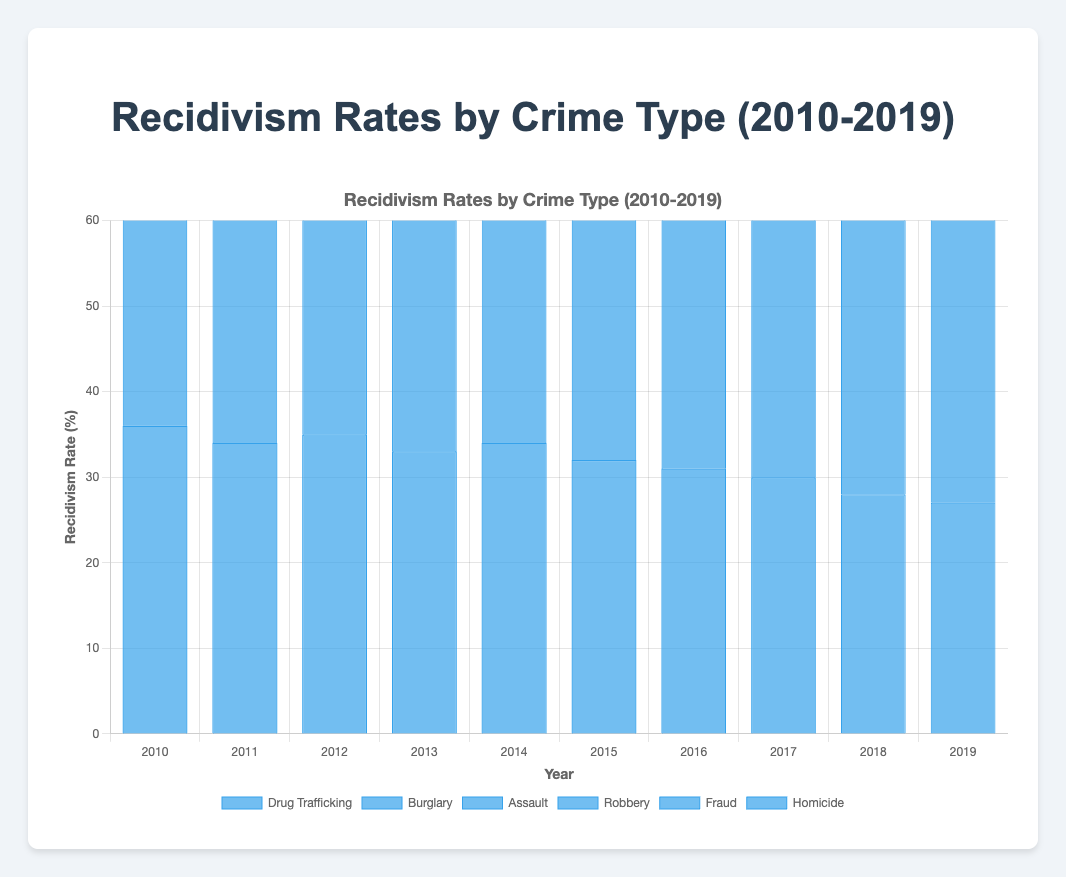What is the recidivism rate for Burglary in 2015? Locate the "Burglary" series and identify the value for the year 2015, which is 44%.
Answer: 44% Between 2010 and 2019, which crime type saw the greatest overall decrease in recidivism rate? Calculate the difference between 2010 and 2019 for each crime type. The largest decrease is for "Homicide," which dropped from 25% to 16%, a 9% decrease.
Answer: Homicide Which year has the lowest overall recidivism rate for Fraud? Find the minimum value in the "Fraud" data series, which is 23% in 2019.
Answer: 2019 How does the recidivism rate of Drug Trafficking in 2010 compare to that of Robbery in 2019? The recidivism rate of Drug Trafficking in 2010 is 36%, and that of Robbery in 2019 is 36%. Both rates are equal.
Answer: Equal What is the average recidivism rate for Assault over the entire decade? Sum the values for "Assault" and divide by the number of years: (42 + 40 + 41 + 39 + 37 + 36 + 35 + 34 + 33 + 32)/10 = 36.9.
Answer: 36.9 Which crime type consistently had the lowest recidivism rate each year? Review all the data points year by year to determine which crime type is consistently the lowest. "Homicide" is the lowest every year.
Answer: Homicide What was the trend in the recidivism rate for Drug Trafficking from 2010 to 2019? Observe the values in the "Drug Trafficking" data series. The rates decreased from 36% in 2010 to 27% in 2019, showing a consistent downward trend.
Answer: Downward How much did the recidivism rate for Burglary decrease from 2010 to 2019? Subtract the value in 2019 from that in 2010 for "Burglary": 50% - 40% = 10%.
Answer: 10% Which crime type had the highest recidivism rate in 2014? Identify the highest value in the 2014 column. "Burglary" had the highest recidivism rate at 45%.
Answer: Burglary 